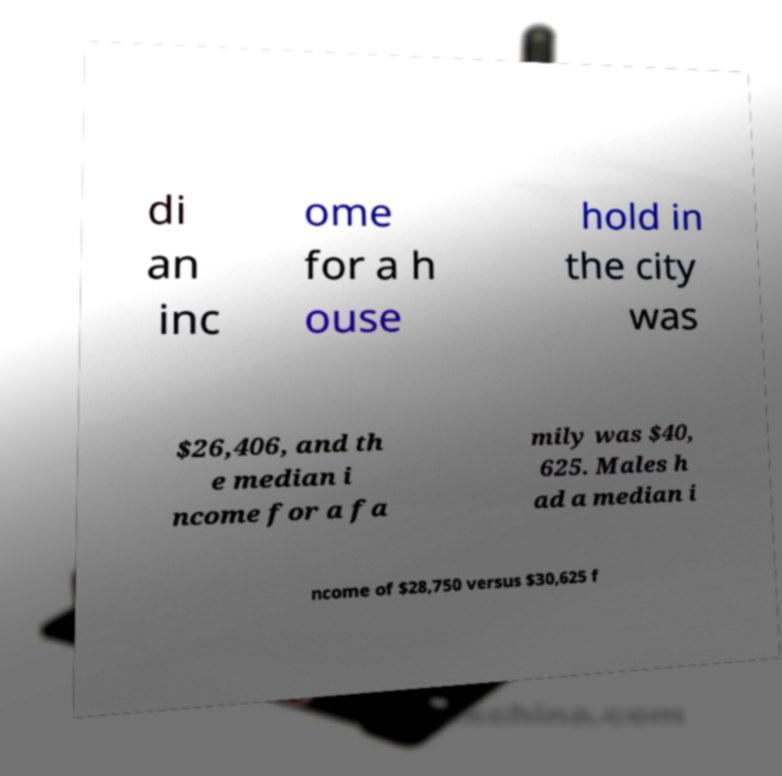Please identify and transcribe the text found in this image. di an inc ome for a h ouse hold in the city was $26,406, and th e median i ncome for a fa mily was $40, 625. Males h ad a median i ncome of $28,750 versus $30,625 f 